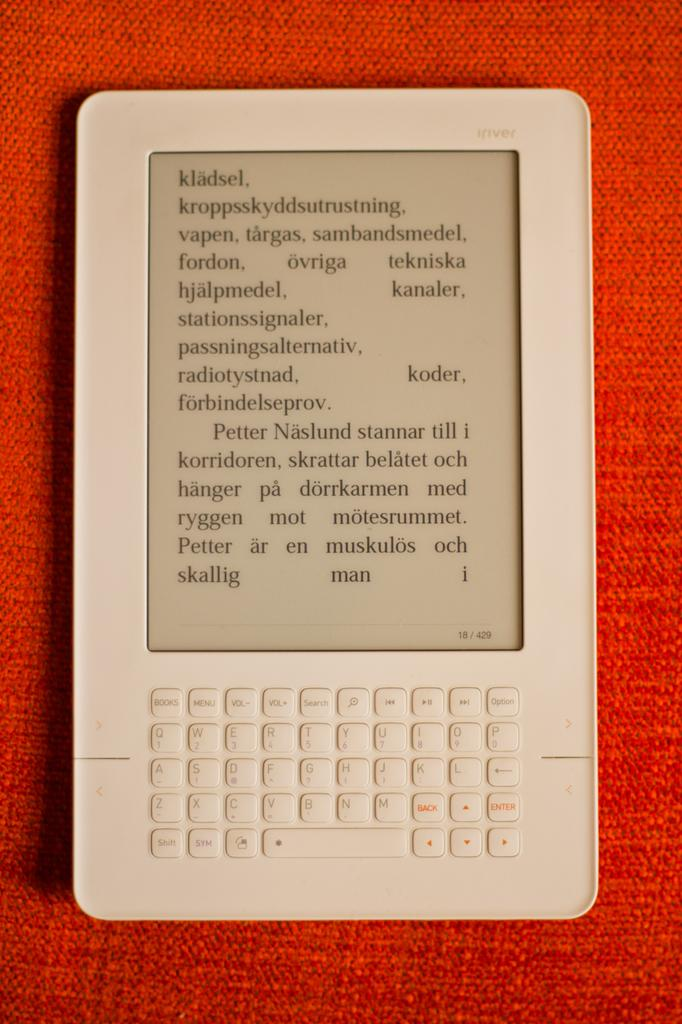Provide a one-sentence caption for the provided image. A tablet displaying some text in a foreign language. 